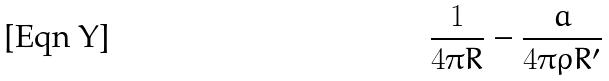<formula> <loc_0><loc_0><loc_500><loc_500>\frac { 1 } { 4 \pi R } - \frac { a } { 4 \pi \rho R ^ { \prime } }</formula> 